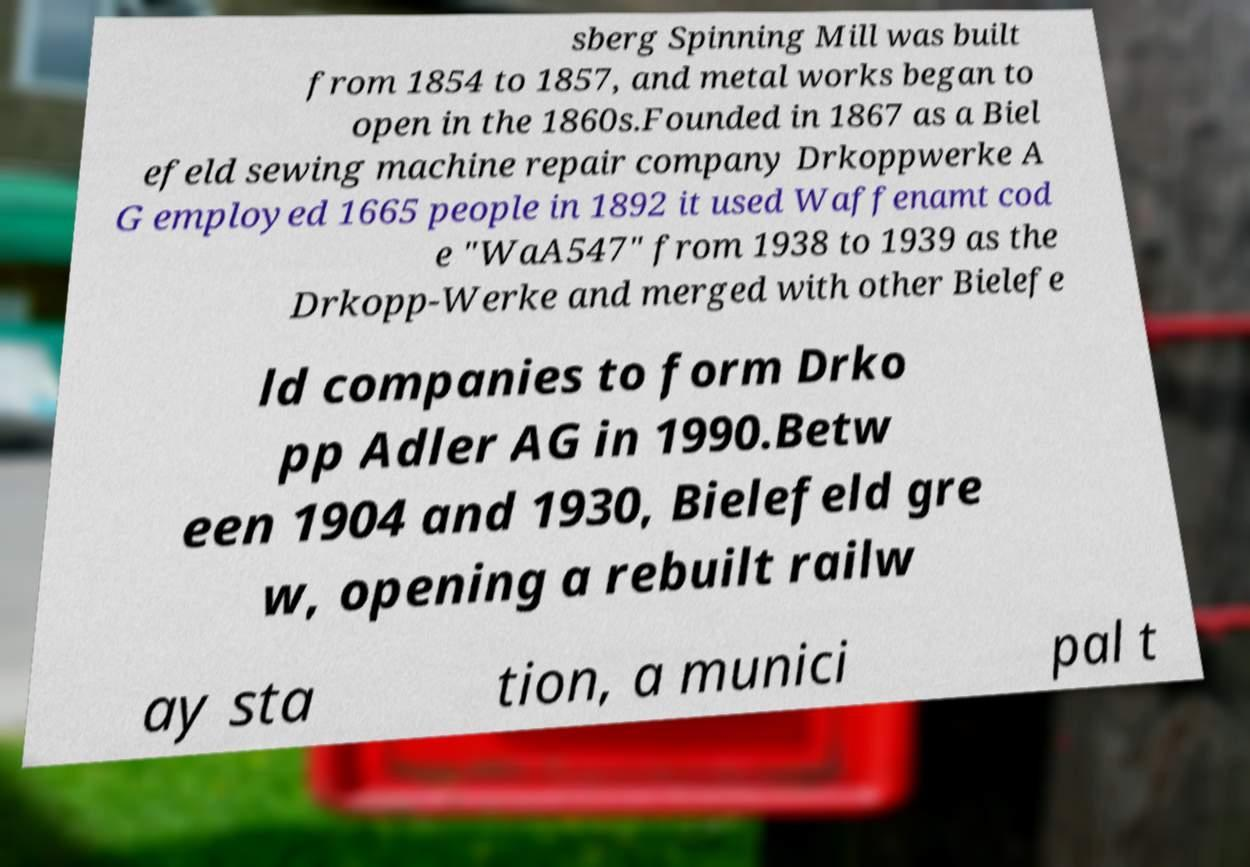Can you accurately transcribe the text from the provided image for me? sberg Spinning Mill was built from 1854 to 1857, and metal works began to open in the 1860s.Founded in 1867 as a Biel efeld sewing machine repair company Drkoppwerke A G employed 1665 people in 1892 it used Waffenamt cod e "WaA547" from 1938 to 1939 as the Drkopp-Werke and merged with other Bielefe ld companies to form Drko pp Adler AG in 1990.Betw een 1904 and 1930, Bielefeld gre w, opening a rebuilt railw ay sta tion, a munici pal t 